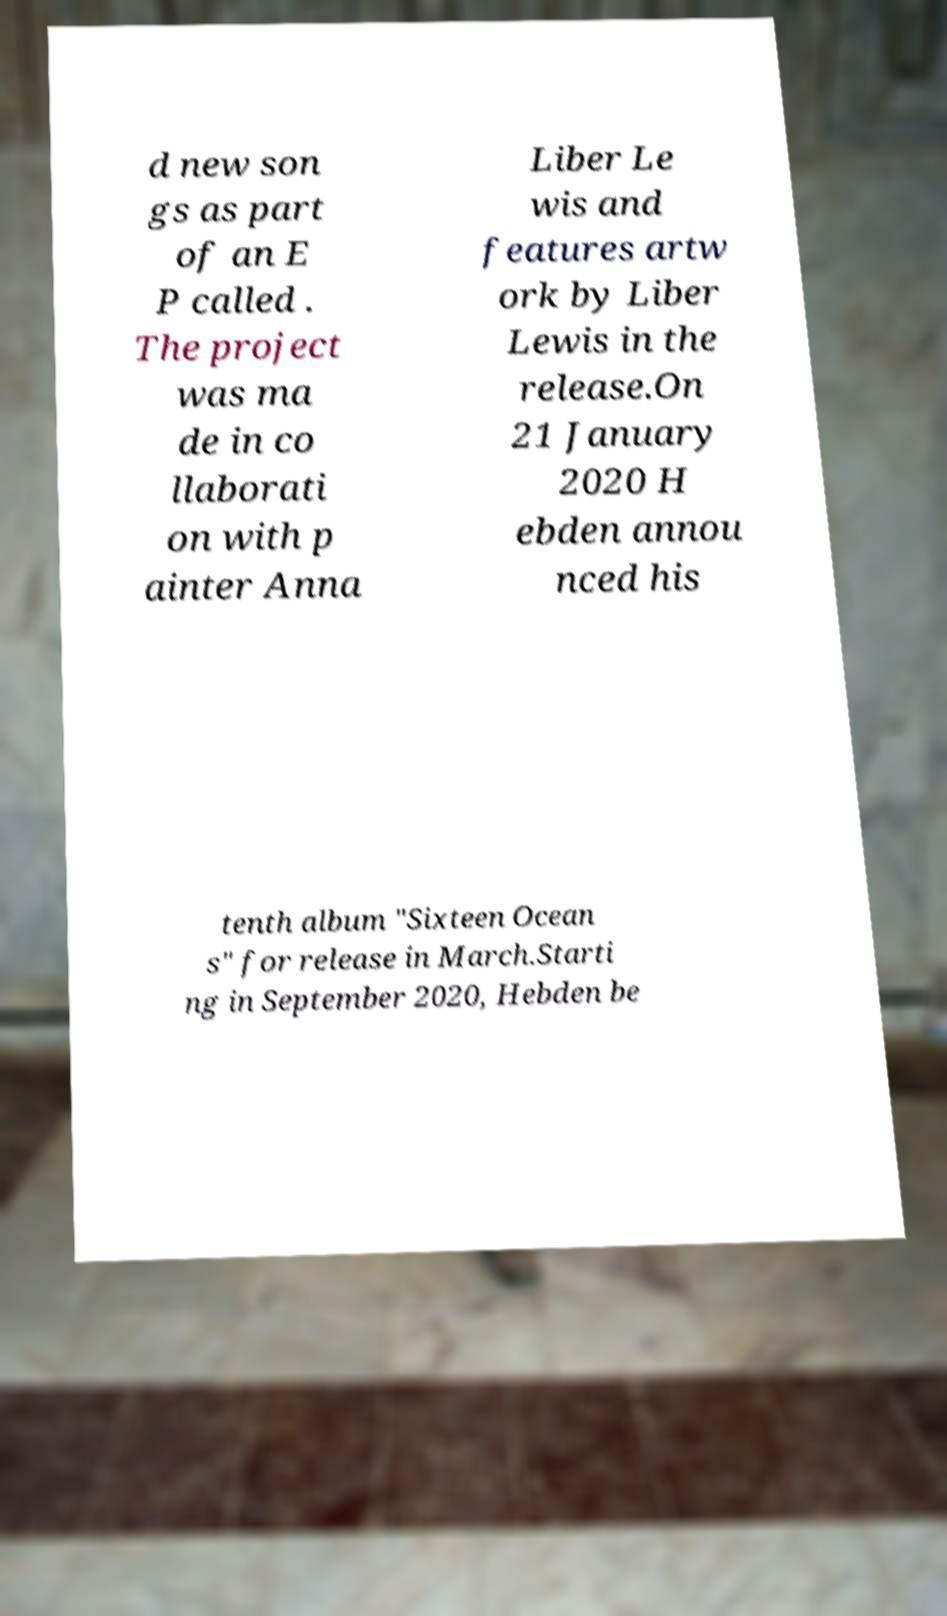Can you accurately transcribe the text from the provided image for me? d new son gs as part of an E P called . The project was ma de in co llaborati on with p ainter Anna Liber Le wis and features artw ork by Liber Lewis in the release.On 21 January 2020 H ebden annou nced his tenth album "Sixteen Ocean s" for release in March.Starti ng in September 2020, Hebden be 